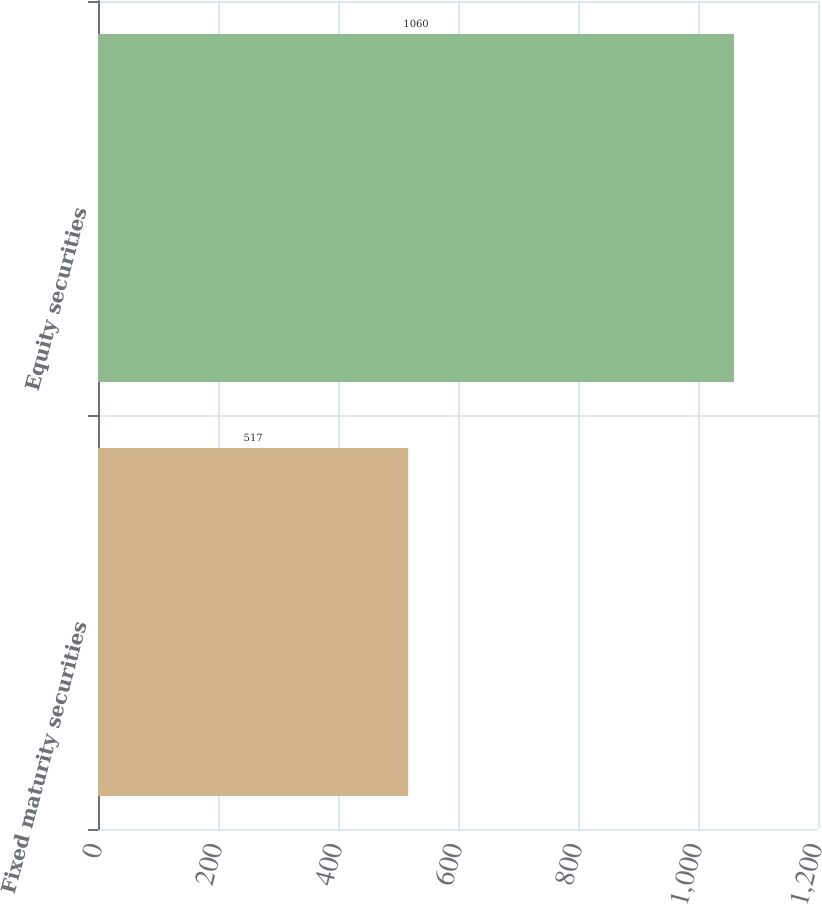Convert chart. <chart><loc_0><loc_0><loc_500><loc_500><bar_chart><fcel>Fixed maturity securities<fcel>Equity securities<nl><fcel>517<fcel>1060<nl></chart> 